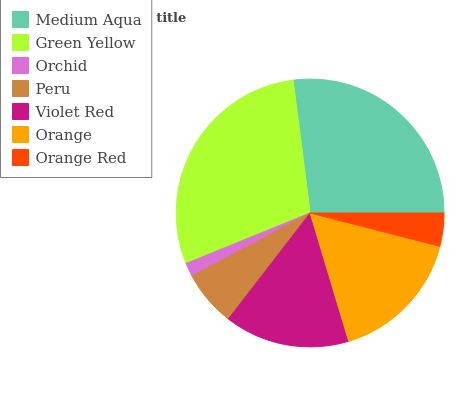Is Orchid the minimum?
Answer yes or no. Yes. Is Green Yellow the maximum?
Answer yes or no. Yes. Is Green Yellow the minimum?
Answer yes or no. No. Is Orchid the maximum?
Answer yes or no. No. Is Green Yellow greater than Orchid?
Answer yes or no. Yes. Is Orchid less than Green Yellow?
Answer yes or no. Yes. Is Orchid greater than Green Yellow?
Answer yes or no. No. Is Green Yellow less than Orchid?
Answer yes or no. No. Is Violet Red the high median?
Answer yes or no. Yes. Is Violet Red the low median?
Answer yes or no. Yes. Is Orchid the high median?
Answer yes or no. No. Is Orange Red the low median?
Answer yes or no. No. 